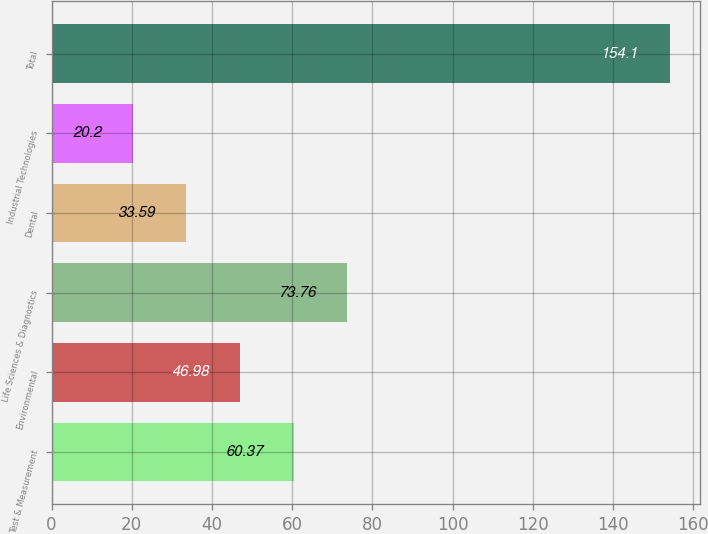Convert chart. <chart><loc_0><loc_0><loc_500><loc_500><bar_chart><fcel>Test & Measurement<fcel>Environmental<fcel>Life Sciences & Diagnostics<fcel>Dental<fcel>Industrial Technologies<fcel>Total<nl><fcel>60.37<fcel>46.98<fcel>73.76<fcel>33.59<fcel>20.2<fcel>154.1<nl></chart> 